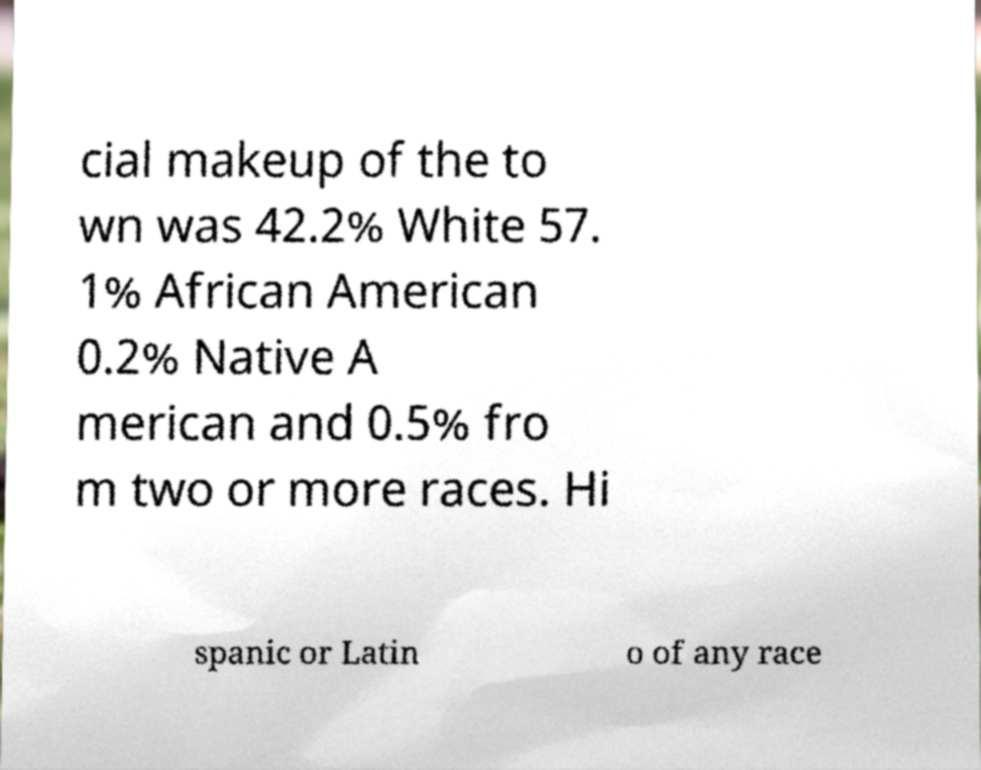I need the written content from this picture converted into text. Can you do that? cial makeup of the to wn was 42.2% White 57. 1% African American 0.2% Native A merican and 0.5% fro m two or more races. Hi spanic or Latin o of any race 